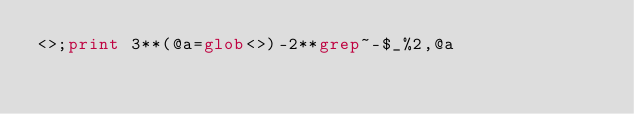<code> <loc_0><loc_0><loc_500><loc_500><_Perl_><>;print 3**(@a=glob<>)-2**grep~-$_%2,@a</code> 